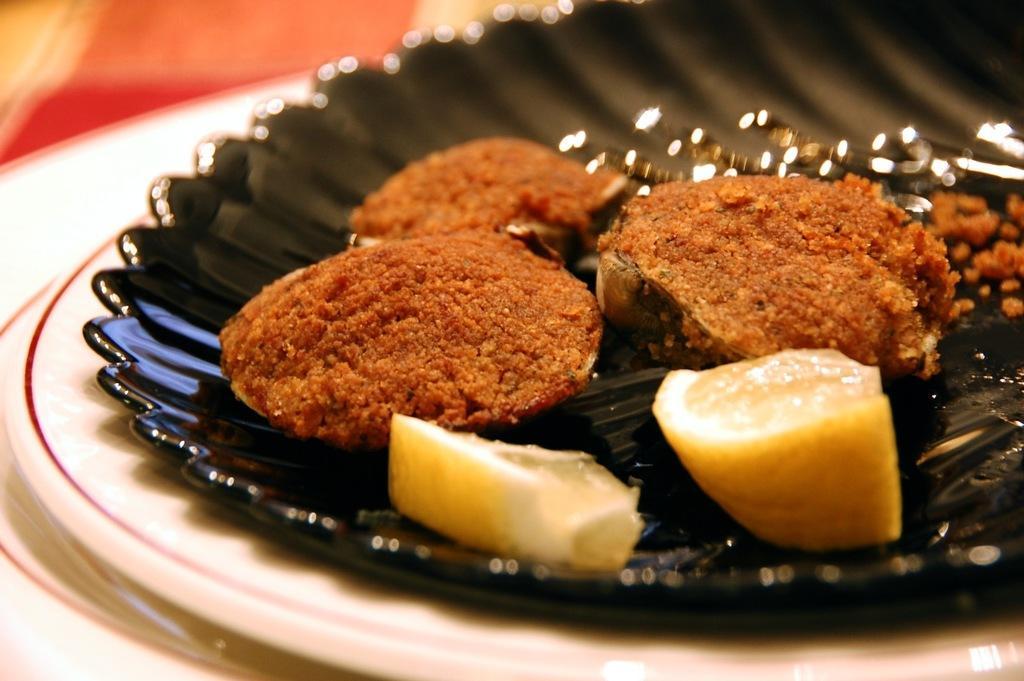How would you summarize this image in a sentence or two? In this picture we can see food in the plate. 